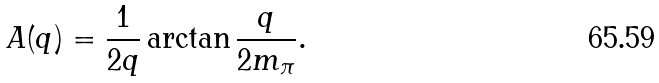Convert formula to latex. <formula><loc_0><loc_0><loc_500><loc_500>A ( q ) = \frac { 1 } { 2 q } \arctan \frac { q } { 2 m _ { \pi } } .</formula> 